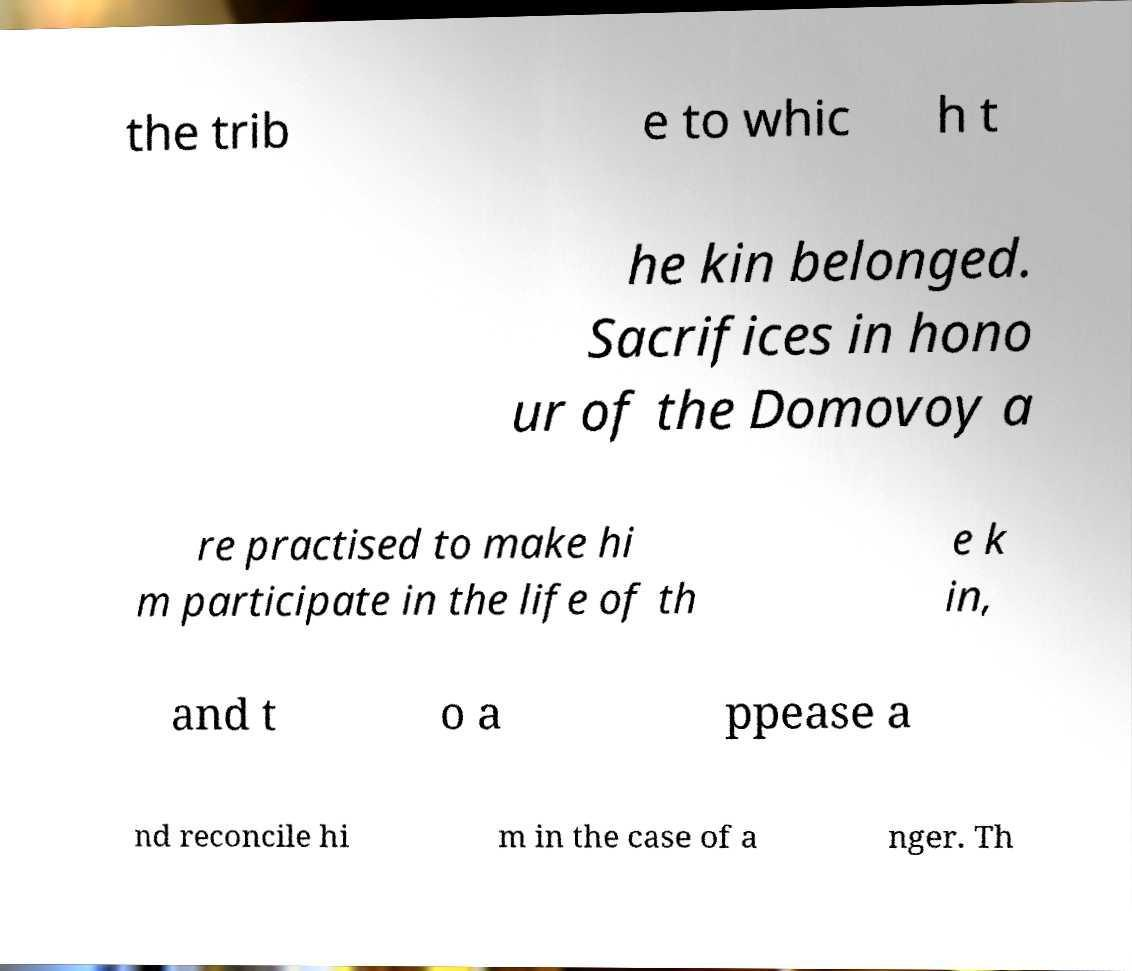Can you read and provide the text displayed in the image?This photo seems to have some interesting text. Can you extract and type it out for me? the trib e to whic h t he kin belonged. Sacrifices in hono ur of the Domovoy a re practised to make hi m participate in the life of th e k in, and t o a ppease a nd reconcile hi m in the case of a nger. Th 